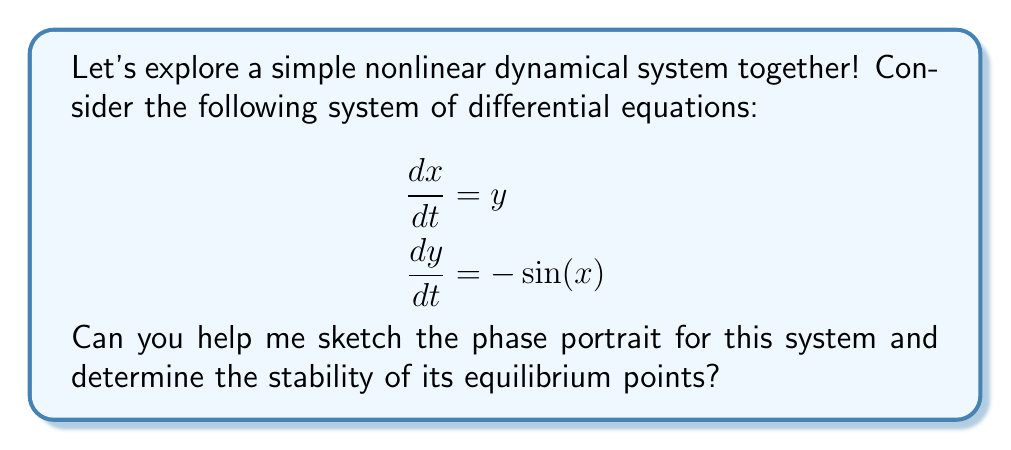Can you answer this question? Great question! Let's approach this step-by-step:

1) First, we need to find the equilibrium points. These occur when both $\frac{dx}{dt}$ and $\frac{dy}{dt}$ are zero:

   $$\begin{aligned}
   y &= 0 \\
   -\sin(x) &= 0
   \end{aligned}$$

   This gives us equilibrium points at $(0,0)$, $(\pi,0)$, $(2\pi,0)$, and so on.

2) Now, let's sketch the phase portrait:

   [asy]
   import graph;
   size(200,200);
   
   void arrow(pair A, pair B, pen p=currentpen)
   {
     draw(A--B,p,Arrow(TeXHead));
   }
   
   for(int i=-2; i<=2; ++i) {
     for(int j=-2; j<=2; ++j) {
       pair z = (pi*i,j);
       pair v = (j,-sin(pi*i));
       v = 0.2*v/length(v);
       arrow(z,z+v);
     }
   }
   
   draw((-2pi,0)--(2pi,0),dashed);
   draw((0,-2)--(0,2),dashed);
   
   dot((0,0));
   dot((pi,0));
   dot((-pi,0));
   
   label("(0,0)", (0,0), SE);
   label("(π,0)", (pi,0), NE);
   label("(-π,0)", (-pi,0), NW);
   [/asy]

3) From the phase portrait, we can see that:
   - $(0,0)$ is a center (stable but not asymptotically stable)
   - $(\pi,0)$, $(-\pi,0)$, and other odd multiples of $\pi$ are saddle points (unstable)

4) To confirm this, we can linearize the system around each equilibrium point:

   At $(0,0)$:
   $$J = \begin{bmatrix} 0 & 1 \\ -\cos(0) & 0 \end{bmatrix} = \begin{bmatrix} 0 & 1 \\ -1 & 0 \end{bmatrix}$$
   
   The eigenvalues are $\pm i$, confirming it's a center.

   At $(\pi,0)$:
   $$J = \begin{bmatrix} 0 & 1 \\ -\cos(\pi) & 0 \end{bmatrix} = \begin{bmatrix} 0 & 1 \\ 1 & 0 \end{bmatrix}$$
   
   The eigenvalues are $\pm 1$, confirming it's a saddle point.

5) The system is conservative (it has a first integral), which explains the closed orbits around $(0,0)$.
Answer: $(0,0)$ is a stable center; $(\pm\pi,0)$ and other odd multiples of $\pi$ are unstable saddle points. 